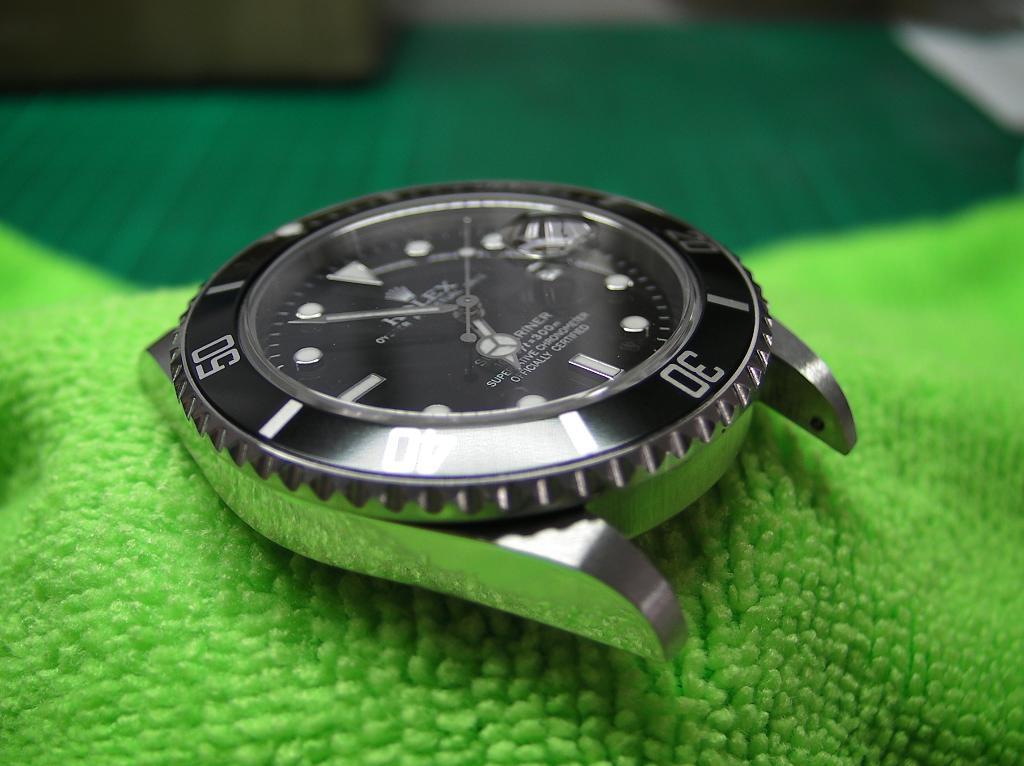What number is upsidedown on the far right?
Your answer should be very brief. 30. 